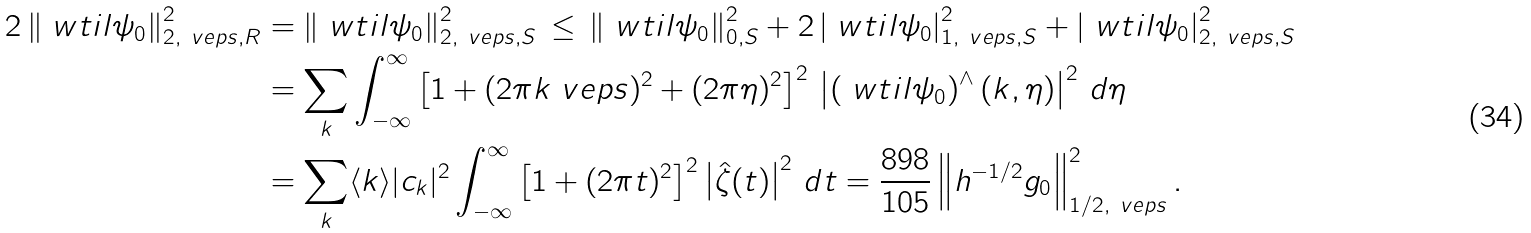<formula> <loc_0><loc_0><loc_500><loc_500>2 \left \| \ w t i l \psi _ { 0 } \right \| ^ { 2 } _ { 2 , \ v e p s , R } & = \left \| \ w t i l \psi _ { 0 } \right \| ^ { 2 } _ { 2 , \ v e p s , S } \, \leq \, \left \| \ w t i l \psi _ { 0 } \right \| ^ { 2 } _ { 0 , S } + 2 \left | \ w t i l \psi _ { 0 } \right | ^ { 2 } _ { 1 , \ v e p s , S } + \left | \ w t i l \psi _ { 0 } \right | ^ { 2 } _ { 2 , \ v e p s , S } \\ & = \sum _ { k } \int _ { - \infty } ^ { \infty } \left [ 1 + ( 2 \pi k \ v e p s ) ^ { 2 } + ( 2 \pi \eta ) ^ { 2 } \right ] ^ { 2 } \, \left | \left ( \ w t i l \psi _ { 0 } \right ) ^ { \wedge } ( k , \eta ) \right | ^ { 2 } \, d \eta \\ & = \sum _ { k } \langle k \rangle | c _ { k } | ^ { 2 } \int _ { - \infty } ^ { \infty } \left [ 1 + ( 2 \pi t ) ^ { 2 } \right ] ^ { 2 } \left | \hat { \zeta } ( t ) \right | ^ { 2 } \, d t = \frac { 8 9 8 } { 1 0 5 } \left \| h ^ { - 1 / 2 } g _ { 0 } \right \| ^ { 2 } _ { 1 / 2 , \ v e p s } .</formula> 